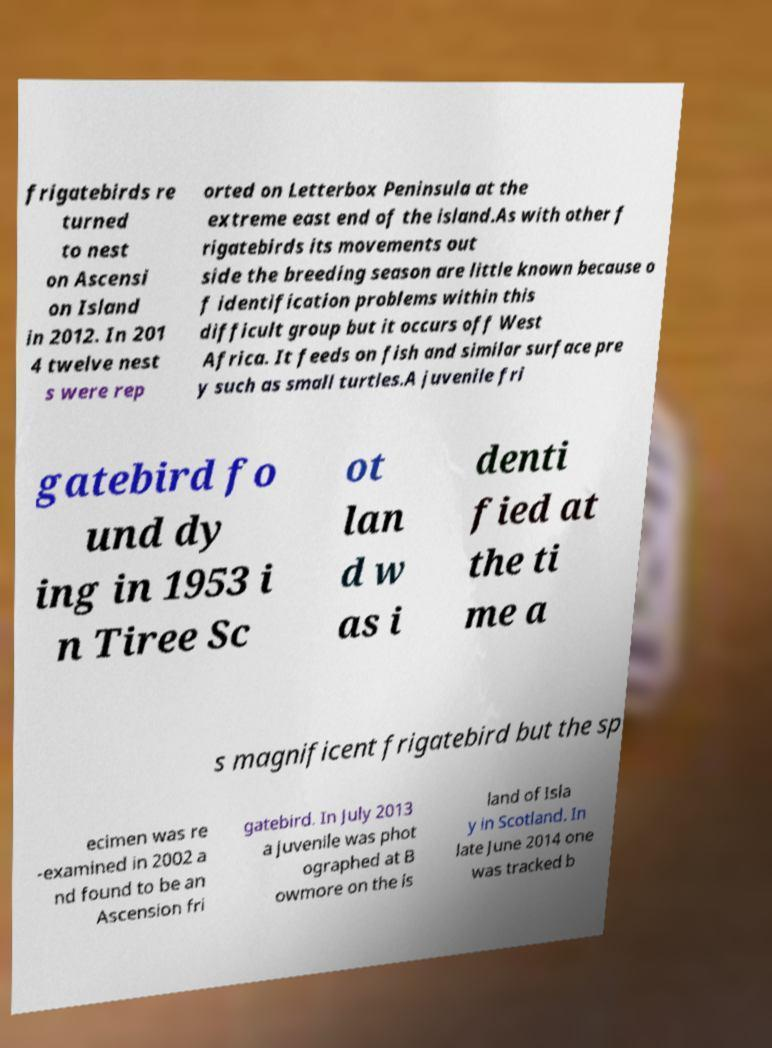What messages or text are displayed in this image? I need them in a readable, typed format. frigatebirds re turned to nest on Ascensi on Island in 2012. In 201 4 twelve nest s were rep orted on Letterbox Peninsula at the extreme east end of the island.As with other f rigatebirds its movements out side the breeding season are little known because o f identification problems within this difficult group but it occurs off West Africa. It feeds on fish and similar surface pre y such as small turtles.A juvenile fri gatebird fo und dy ing in 1953 i n Tiree Sc ot lan d w as i denti fied at the ti me a s magnificent frigatebird but the sp ecimen was re -examined in 2002 a nd found to be an Ascension fri gatebird. In July 2013 a juvenile was phot ographed at B owmore on the is land of Isla y in Scotland. In late June 2014 one was tracked b 